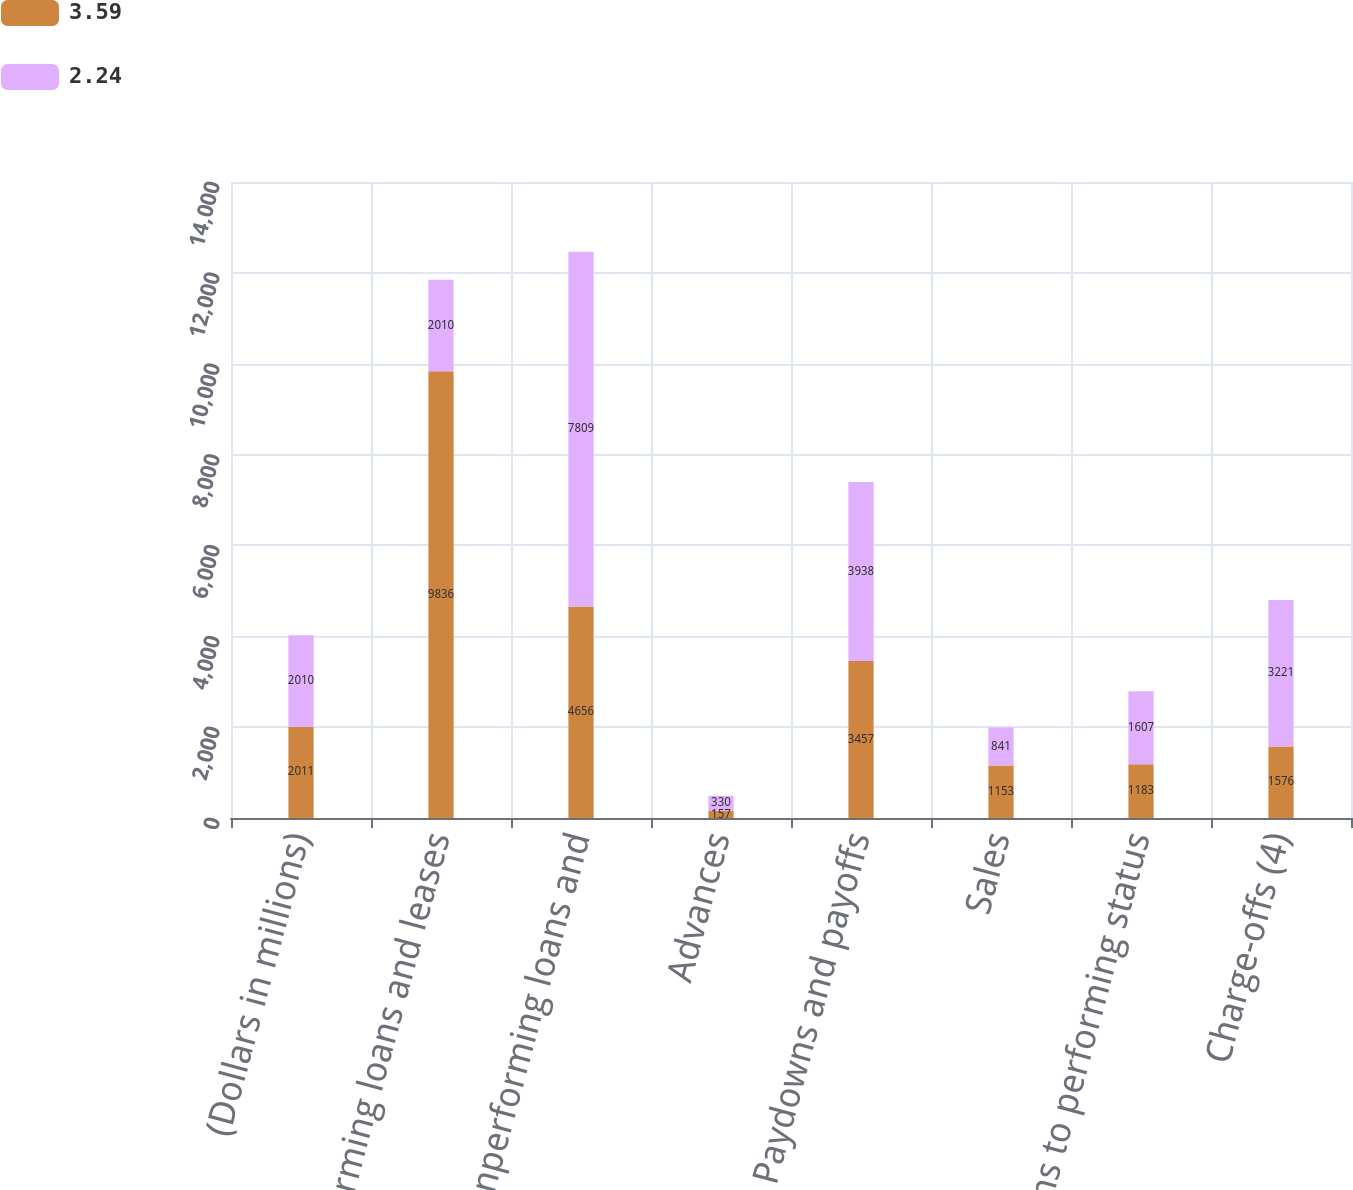Convert chart. <chart><loc_0><loc_0><loc_500><loc_500><stacked_bar_chart><ecel><fcel>(Dollars in millions)<fcel>Nonperforming loans and leases<fcel>New nonperforming loans and<fcel>Advances<fcel>Paydowns and payoffs<fcel>Sales<fcel>Returns to performing status<fcel>Charge-offs (4)<nl><fcel>3.59<fcel>2011<fcel>9836<fcel>4656<fcel>157<fcel>3457<fcel>1153<fcel>1183<fcel>1576<nl><fcel>2.24<fcel>2010<fcel>2010<fcel>7809<fcel>330<fcel>3938<fcel>841<fcel>1607<fcel>3221<nl></chart> 